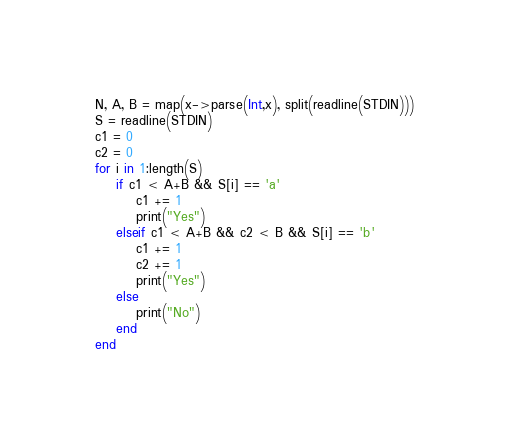<code> <loc_0><loc_0><loc_500><loc_500><_Julia_>N, A, B = map(x->parse(Int,x), split(readline(STDIN)))
S = readline(STDIN)
c1 = 0
c2 = 0
for i in 1:length(S)
    if c1 < A+B && S[i] == 'a'
        c1 += 1
        print("Yes")
    elseif c1 < A+B && c2 < B && S[i] == 'b'
        c1 += 1
        c2 += 1
        print("Yes")
    else
        print("No")
    end
end</code> 